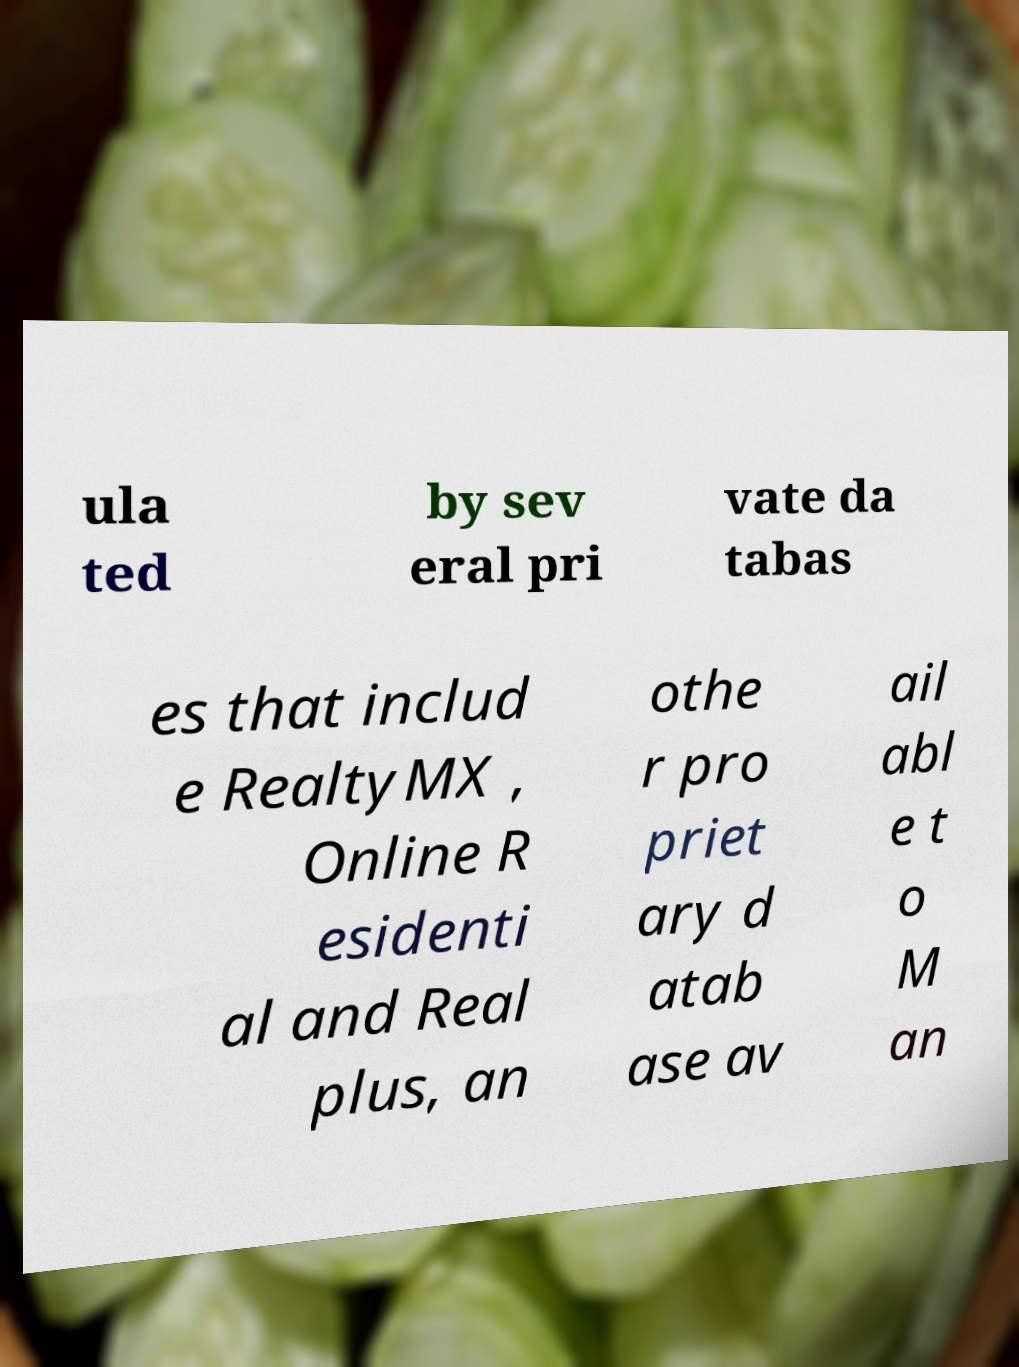There's text embedded in this image that I need extracted. Can you transcribe it verbatim? ula ted by sev eral pri vate da tabas es that includ e RealtyMX , Online R esidenti al and Real plus, an othe r pro priet ary d atab ase av ail abl e t o M an 